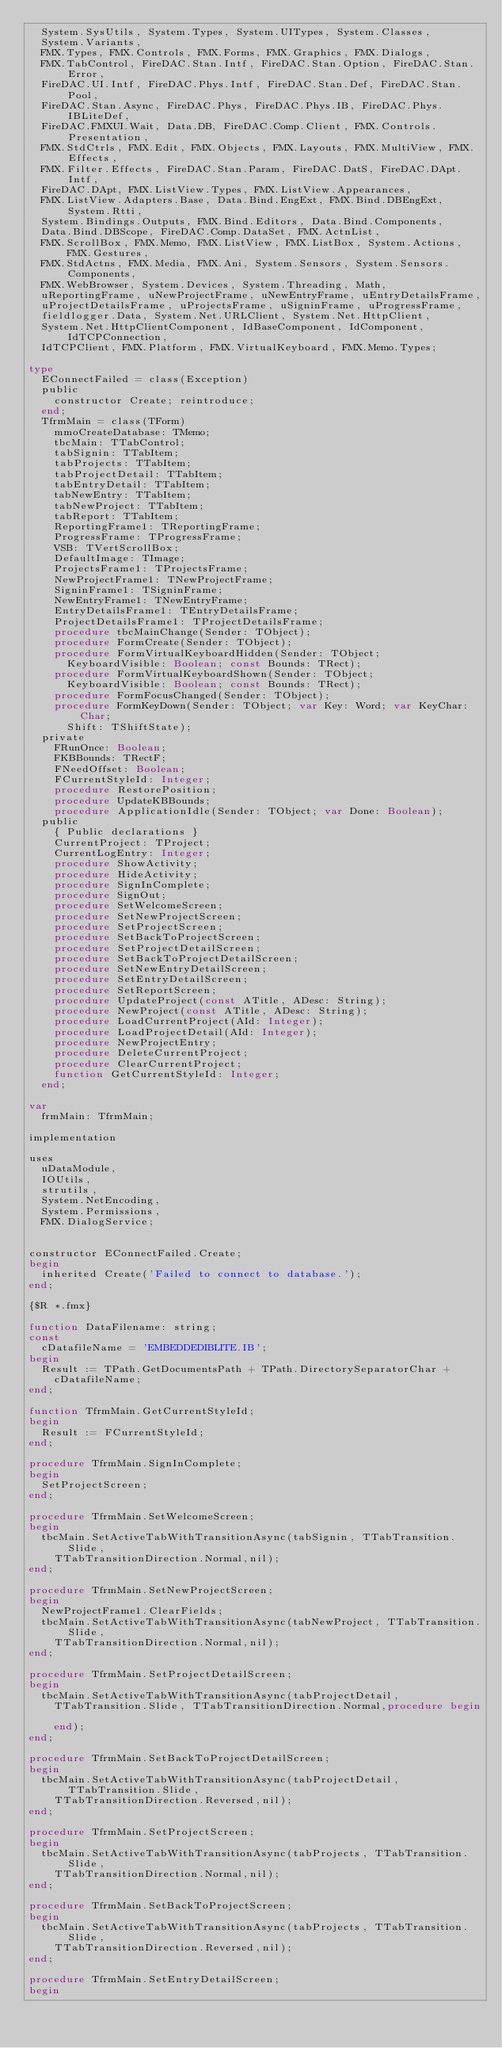Convert code to text. <code><loc_0><loc_0><loc_500><loc_500><_Pascal_>  System.SysUtils, System.Types, System.UITypes, System.Classes,
  System.Variants,
  FMX.Types, FMX.Controls, FMX.Forms, FMX.Graphics, FMX.Dialogs,
  FMX.TabControl, FireDAC.Stan.Intf, FireDAC.Stan.Option, FireDAC.Stan.Error,
  FireDAC.UI.Intf, FireDAC.Phys.Intf, FireDAC.Stan.Def, FireDAC.Stan.Pool,
  FireDAC.Stan.Async, FireDAC.Phys, FireDAC.Phys.IB, FireDAC.Phys.IBLiteDef,
  FireDAC.FMXUI.Wait, Data.DB, FireDAC.Comp.Client, FMX.Controls.Presentation,
  FMX.StdCtrls, FMX.Edit, FMX.Objects, FMX.Layouts, FMX.MultiView, FMX.Effects,
  FMX.Filter.Effects, FireDAC.Stan.Param, FireDAC.DatS, FireDAC.DApt.Intf,
  FireDAC.DApt, FMX.ListView.Types, FMX.ListView.Appearances,
  FMX.ListView.Adapters.Base, Data.Bind.EngExt, FMX.Bind.DBEngExt, System.Rtti,
  System.Bindings.Outputs, FMX.Bind.Editors, Data.Bind.Components,
  Data.Bind.DBScope, FireDAC.Comp.DataSet, FMX.ActnList,
  FMX.ScrollBox, FMX.Memo, FMX.ListView, FMX.ListBox, System.Actions, FMX.Gestures,
  FMX.StdActns, FMX.Media, FMX.Ani, System.Sensors, System.Sensors.Components,
  FMX.WebBrowser, System.Devices, System.Threading, Math,
  uReportingFrame, uNewProjectFrame, uNewEntryFrame, uEntryDetailsFrame,
  uProjectDetailsFrame, uProjectsFrame, uSigninFrame, uProgressFrame,
  fieldlogger.Data, System.Net.URLClient, System.Net.HttpClient,
  System.Net.HttpClientComponent, IdBaseComponent, IdComponent, IdTCPConnection,
  IdTCPClient, FMX.Platform, FMX.VirtualKeyboard, FMX.Memo.Types;

type
  EConnectFailed = class(Exception)
  public
    constructor Create; reintroduce;
  end;
  TfrmMain = class(TForm)
    mmoCreateDatabase: TMemo;
    tbcMain: TTabControl;
    tabSignin: TTabItem;
    tabProjects: TTabItem;
    tabProjectDetail: TTabItem;
    tabEntryDetail: TTabItem;
    tabNewEntry: TTabItem;
    tabNewProject: TTabItem;
    tabReport: TTabItem;
    ReportingFrame1: TReportingFrame;
    ProgressFrame: TProgressFrame;
    VSB: TVertScrollBox;
    DefaultImage: TImage;
    ProjectsFrame1: TProjectsFrame;
    NewProjectFrame1: TNewProjectFrame;
    SigninFrame1: TSigninFrame;
    NewEntryFrame1: TNewEntryFrame;
    EntryDetailsFrame1: TEntryDetailsFrame;
    ProjectDetailsFrame1: TProjectDetailsFrame;
    procedure tbcMainChange(Sender: TObject);
    procedure FormCreate(Sender: TObject);
    procedure FormVirtualKeyboardHidden(Sender: TObject;
      KeyboardVisible: Boolean; const Bounds: TRect);
    procedure FormVirtualKeyboardShown(Sender: TObject;
      KeyboardVisible: Boolean; const Bounds: TRect);
    procedure FormFocusChanged(Sender: TObject);
    procedure FormKeyDown(Sender: TObject; var Key: Word; var KeyChar: Char;
      Shift: TShiftState);
	private
		FRunOnce: Boolean;
		FKBBounds: TRectF;
		FNeedOffset: Boolean;
		FCurrentStyleId: Integer;
		procedure RestorePosition;
    procedure UpdateKBBounds;
    procedure ApplicationIdle(Sender: TObject; var Done: Boolean);
  public
    { Public declarations }
    CurrentProject: TProject;
    CurrentLogEntry: Integer;
    procedure ShowActivity;
    procedure HideActivity;
    procedure SignInComplete;
    procedure SignOut;
    procedure SetWelcomeScreen;
    procedure SetNewProjectScreen;
    procedure SetProjectScreen;
    procedure SetBackToProjectScreen;
    procedure SetProjectDetailScreen;
    procedure SetBackToProjectDetailScreen;
    procedure SetNewEntryDetailScreen;
    procedure SetEntryDetailScreen;
    procedure SetReportScreen;
    procedure UpdateProject(const ATitle, ADesc: String);
    procedure NewProject(const ATitle, ADesc: String);
    procedure LoadCurrentProject(AId: Integer);
    procedure LoadProjectDetail(AId: Integer);
    procedure NewProjectEntry;
    procedure DeleteCurrentProject;
    procedure ClearCurrentProject;
    function GetCurrentStyleId: Integer;
  end;

var
  frmMain: TfrmMain;

implementation

uses
  uDataModule,
  IOUtils,
  strutils,
  System.NetEncoding,
  System.Permissions,
  FMX.DialogService;


constructor EConnectFailed.Create;
begin
  inherited Create('Failed to connect to database.');
end;

{$R *.fmx}

function DataFilename: string;
const
  cDatafileName = 'EMBEDDEDIBLITE.IB';
begin
  Result := TPath.GetDocumentsPath + TPath.DirectorySeparatorChar +
    cDatafileName;
end;

function TfrmMain.GetCurrentStyleId;
begin
  Result := FCurrentStyleId;
end;

procedure TfrmMain.SignInComplete;
begin
  SetProjectScreen;
end;

procedure TfrmMain.SetWelcomeScreen;
begin
  tbcMain.SetActiveTabWithTransitionAsync(tabSignin, TTabTransition.Slide,
    TTabTransitionDirection.Normal,nil);
end;

procedure TfrmMain.SetNewProjectScreen;
begin
  NewProjectFrame1.ClearFields;
  tbcMain.SetActiveTabWithTransitionAsync(tabNewProject, TTabTransition.Slide,
    TTabTransitionDirection.Normal,nil);
end;

procedure TfrmMain.SetProjectDetailScreen;
begin
  tbcMain.SetActiveTabWithTransitionAsync(tabProjectDetail,
    TTabTransition.Slide, TTabTransitionDirection.Normal,procedure begin

    end);
end;

procedure TfrmMain.SetBackToProjectDetailScreen;
begin
  tbcMain.SetActiveTabWithTransitionAsync(tabProjectDetail, TTabTransition.Slide,
    TTabTransitionDirection.Reversed,nil);
end;

procedure TfrmMain.SetProjectScreen;
begin
  tbcMain.SetActiveTabWithTransitionAsync(tabProjects, TTabTransition.Slide,
    TTabTransitionDirection.Normal,nil);
end;

procedure TfrmMain.SetBackToProjectScreen;
begin
  tbcMain.SetActiveTabWithTransitionAsync(tabProjects, TTabTransition.Slide,
    TTabTransitionDirection.Reversed,nil);
end;

procedure TfrmMain.SetEntryDetailScreen;
begin</code> 